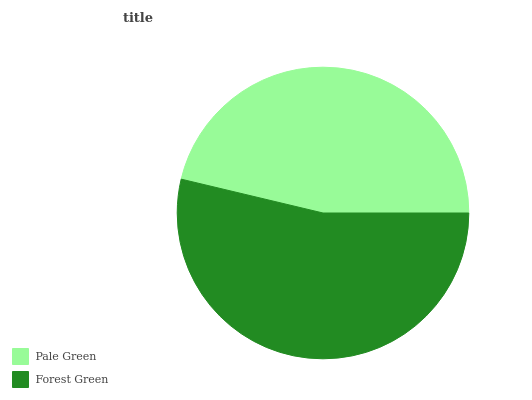Is Pale Green the minimum?
Answer yes or no. Yes. Is Forest Green the maximum?
Answer yes or no. Yes. Is Forest Green the minimum?
Answer yes or no. No. Is Forest Green greater than Pale Green?
Answer yes or no. Yes. Is Pale Green less than Forest Green?
Answer yes or no. Yes. Is Pale Green greater than Forest Green?
Answer yes or no. No. Is Forest Green less than Pale Green?
Answer yes or no. No. Is Forest Green the high median?
Answer yes or no. Yes. Is Pale Green the low median?
Answer yes or no. Yes. Is Pale Green the high median?
Answer yes or no. No. Is Forest Green the low median?
Answer yes or no. No. 